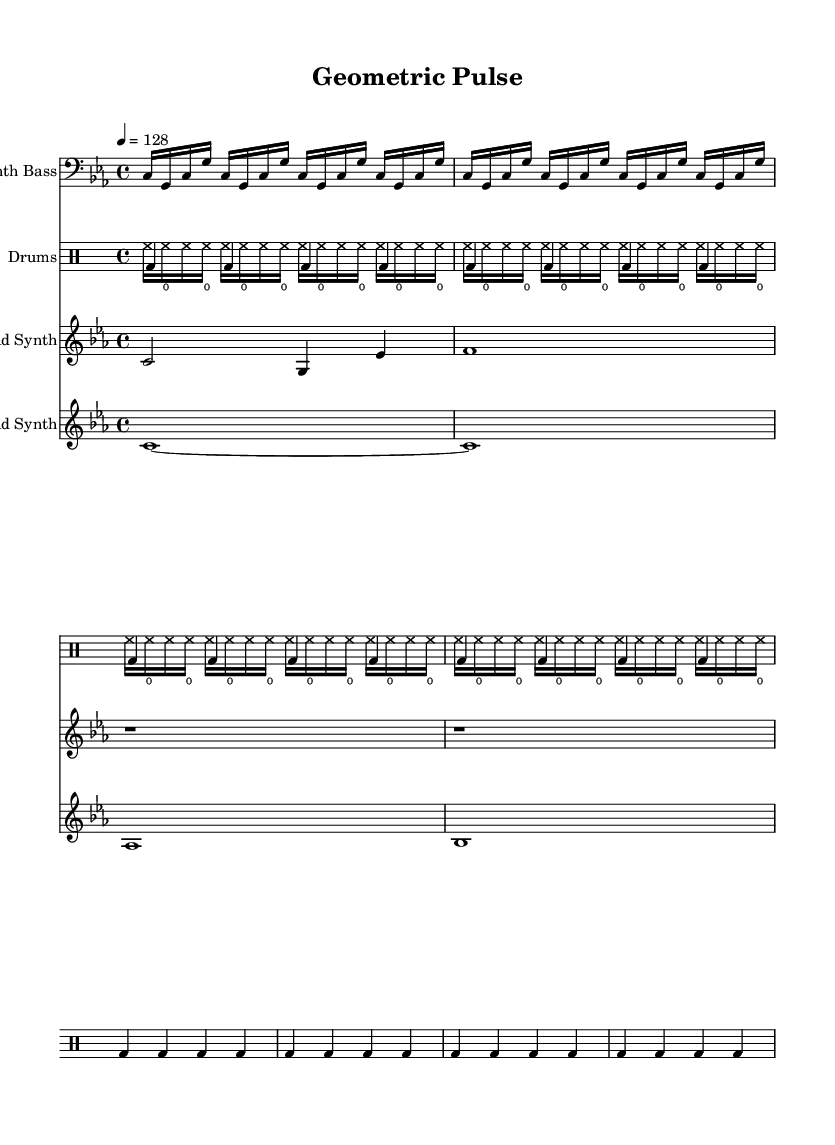What is the key signature of this music? The key signature is indicated at the beginning of the score, showing three flats, which corresponds to the key of C minor.
Answer: C minor What is the time signature of the piece? The time signature is represented as 4/4 at the start of the score, indicating four beats per measure and a quarter note receives one beat.
Answer: 4/4 What is the tempo marking for this composition? The tempo marking is indicated in the score as "4 = 128," which describes the speed at which the piece should be performed, specifying 128 beats per minute.
Answer: 128 How many measures are in the lead synth section? Counting the measures in the lead synth part from the score, there are two distinct measures before the rests are introduced.
Answer: 2 What type of synth is used for the bass line? In the score, the staff labeled "Synth Bass" indicates that the sound produced is from a synthesizer that is designed to create bass sounds.
Answer: Synth Bass How many times is the kick drum pattern repeated? The kick drum pattern indicated in the score shows it is repeated eight times, as marked by the "repeat unfold 8" instruction.
Answer: 8 What rhythmic subdivision is used for the hi-hat? The hi-hat rhythm in the score is notated as sixteenth notes, shown by the rhythmic values that correspond to the higher-frequency percussion characteristic of electronic music.
Answer: Sixteenth notes 